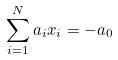Convert formula to latex. <formula><loc_0><loc_0><loc_500><loc_500>\sum _ { i = 1 } ^ { N } a _ { i } x _ { i } = - a _ { 0 }</formula> 